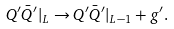<formula> <loc_0><loc_0><loc_500><loc_500>Q ^ { \prime } \bar { Q } ^ { \prime } | _ { L } \rightarrow Q ^ { \prime } \bar { Q } ^ { \prime } | _ { L - 1 } + g ^ { \prime } .</formula> 